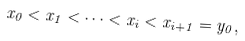<formula> <loc_0><loc_0><loc_500><loc_500>x _ { 0 } < x _ { 1 } < \cdots < x _ { i } < x _ { i + 1 } = y _ { 0 } ,</formula> 